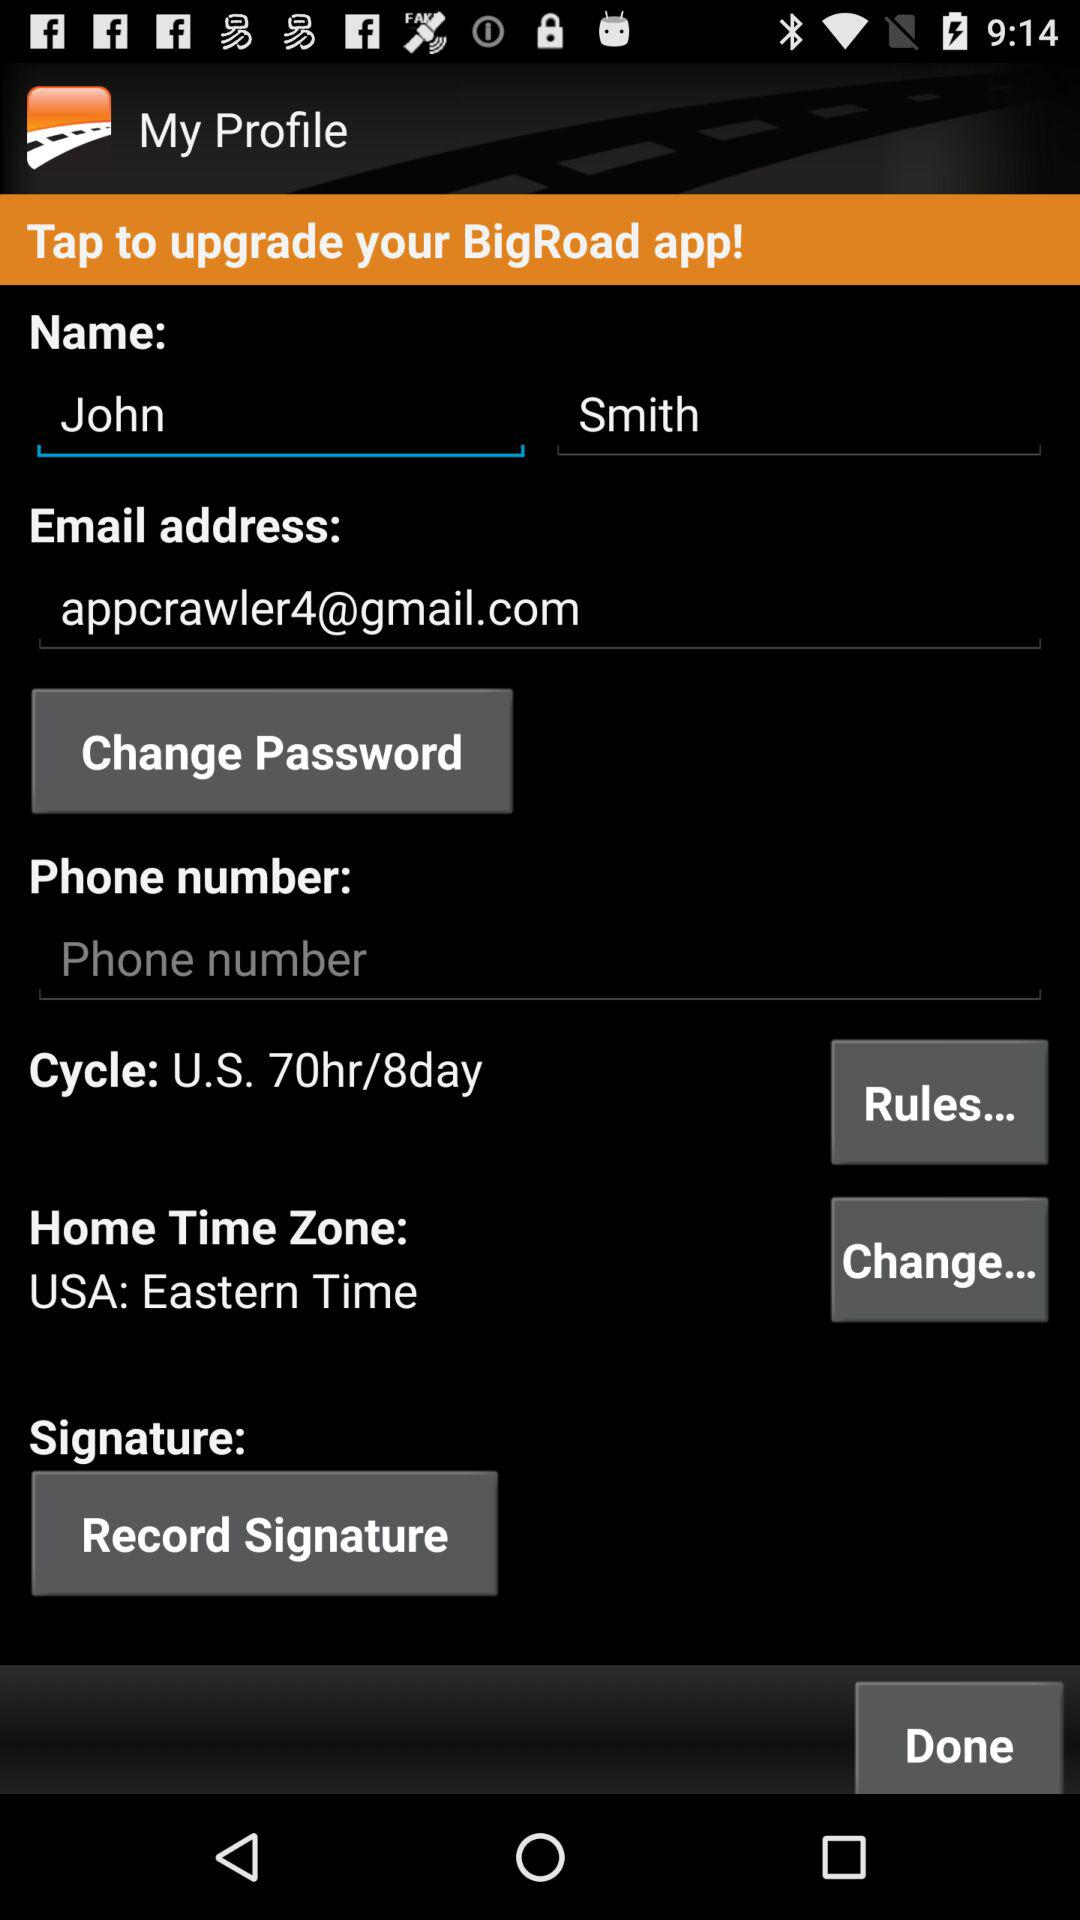What's the cycle? The cycle is "U.S. 70hr/8day". 